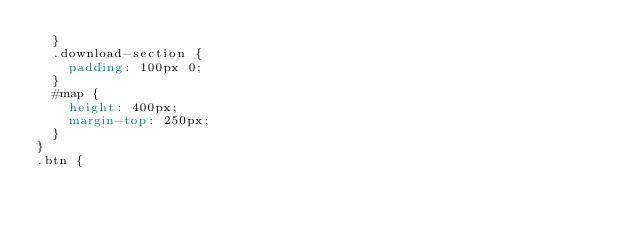Convert code to text. <code><loc_0><loc_0><loc_500><loc_500><_CSS_>  }
  .download-section {
    padding: 100px 0;
  }
  #map {
    height: 400px;
    margin-top: 250px;
  }
}
.btn {</code> 